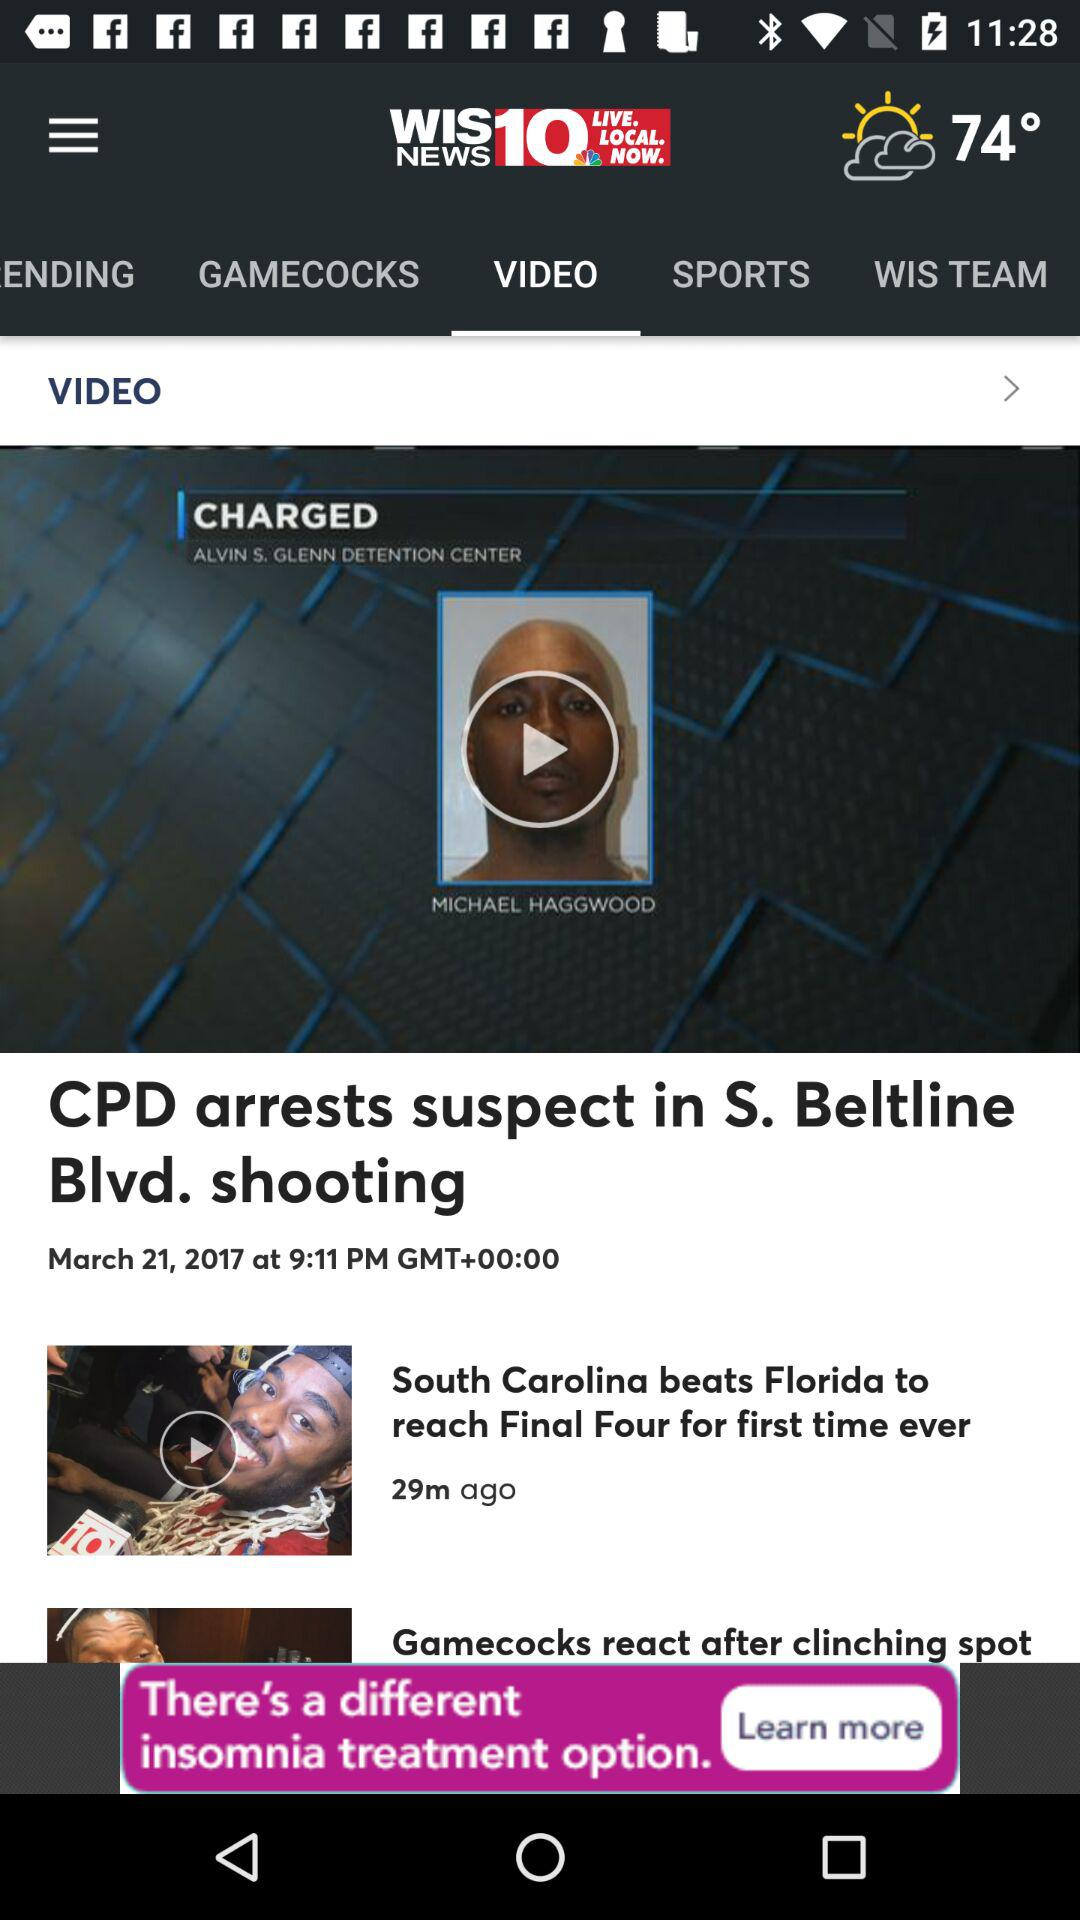What is the name of the news channel? The name of the news channel is "WIS 10 NEWS". 